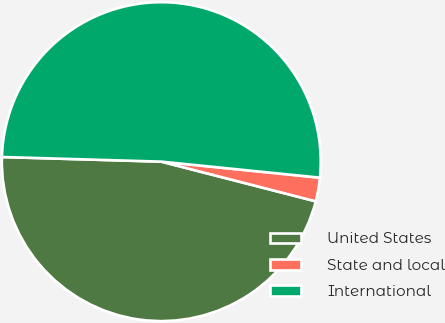Convert chart. <chart><loc_0><loc_0><loc_500><loc_500><pie_chart><fcel>United States<fcel>State and local<fcel>International<nl><fcel>46.46%<fcel>2.4%<fcel>51.14%<nl></chart> 